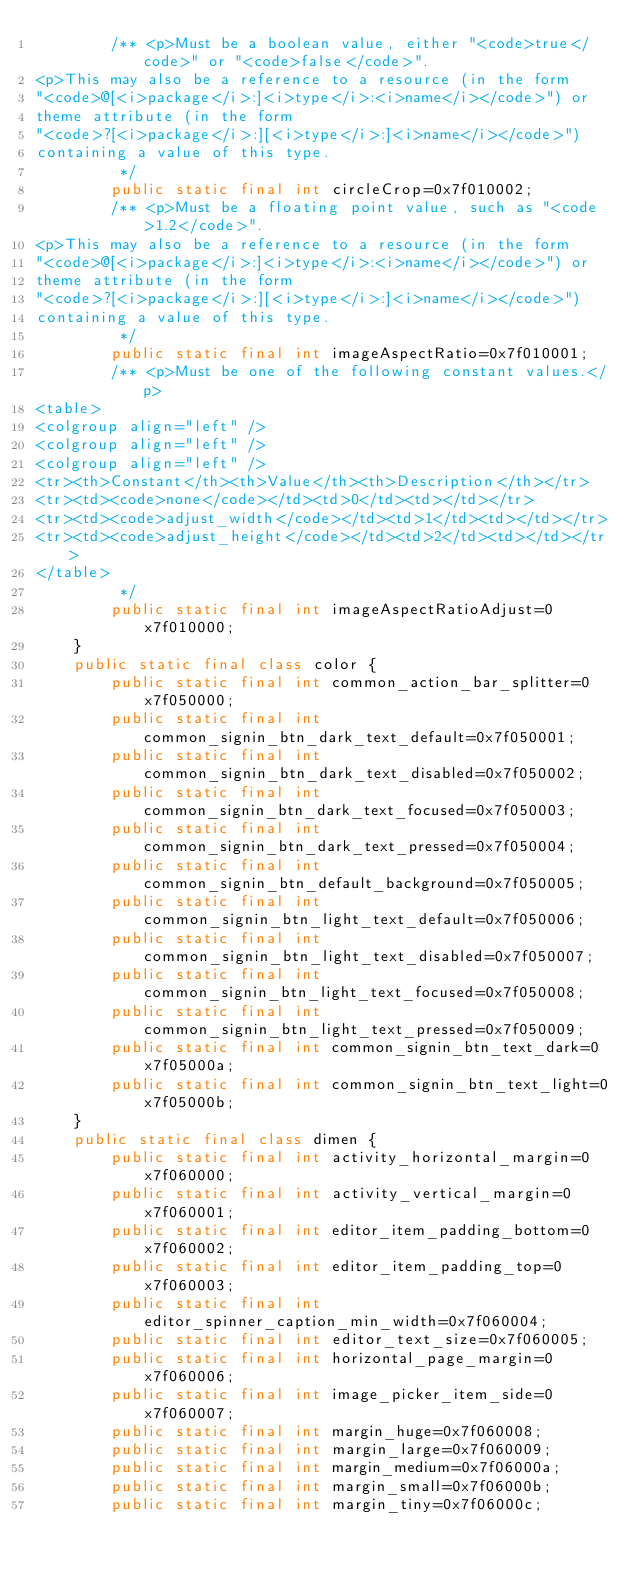Convert code to text. <code><loc_0><loc_0><loc_500><loc_500><_Java_>        /** <p>Must be a boolean value, either "<code>true</code>" or "<code>false</code>".
<p>This may also be a reference to a resource (in the form
"<code>@[<i>package</i>:]<i>type</i>:<i>name</i></code>") or
theme attribute (in the form
"<code>?[<i>package</i>:][<i>type</i>:]<i>name</i></code>")
containing a value of this type.
         */
        public static final int circleCrop=0x7f010002;
        /** <p>Must be a floating point value, such as "<code>1.2</code>".
<p>This may also be a reference to a resource (in the form
"<code>@[<i>package</i>:]<i>type</i>:<i>name</i></code>") or
theme attribute (in the form
"<code>?[<i>package</i>:][<i>type</i>:]<i>name</i></code>")
containing a value of this type.
         */
        public static final int imageAspectRatio=0x7f010001;
        /** <p>Must be one of the following constant values.</p>
<table>
<colgroup align="left" />
<colgroup align="left" />
<colgroup align="left" />
<tr><th>Constant</th><th>Value</th><th>Description</th></tr>
<tr><td><code>none</code></td><td>0</td><td></td></tr>
<tr><td><code>adjust_width</code></td><td>1</td><td></td></tr>
<tr><td><code>adjust_height</code></td><td>2</td><td></td></tr>
</table>
         */
        public static final int imageAspectRatioAdjust=0x7f010000;
    }
    public static final class color {
        public static final int common_action_bar_splitter=0x7f050000;
        public static final int common_signin_btn_dark_text_default=0x7f050001;
        public static final int common_signin_btn_dark_text_disabled=0x7f050002;
        public static final int common_signin_btn_dark_text_focused=0x7f050003;
        public static final int common_signin_btn_dark_text_pressed=0x7f050004;
        public static final int common_signin_btn_default_background=0x7f050005;
        public static final int common_signin_btn_light_text_default=0x7f050006;
        public static final int common_signin_btn_light_text_disabled=0x7f050007;
        public static final int common_signin_btn_light_text_focused=0x7f050008;
        public static final int common_signin_btn_light_text_pressed=0x7f050009;
        public static final int common_signin_btn_text_dark=0x7f05000a;
        public static final int common_signin_btn_text_light=0x7f05000b;
    }
    public static final class dimen {
        public static final int activity_horizontal_margin=0x7f060000;
        public static final int activity_vertical_margin=0x7f060001;
        public static final int editor_item_padding_bottom=0x7f060002;
        public static final int editor_item_padding_top=0x7f060003;
        public static final int editor_spinner_caption_min_width=0x7f060004;
        public static final int editor_text_size=0x7f060005;
        public static final int horizontal_page_margin=0x7f060006;
        public static final int image_picker_item_side=0x7f060007;
        public static final int margin_huge=0x7f060008;
        public static final int margin_large=0x7f060009;
        public static final int margin_medium=0x7f06000a;
        public static final int margin_small=0x7f06000b;
        public static final int margin_tiny=0x7f06000c;</code> 